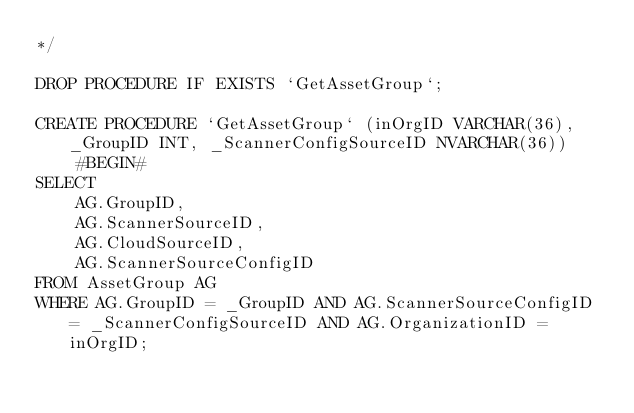<code> <loc_0><loc_0><loc_500><loc_500><_SQL_>*/

DROP PROCEDURE IF EXISTS `GetAssetGroup`;

CREATE PROCEDURE `GetAssetGroup` (inOrgID VARCHAR(36), _GroupID INT, _ScannerConfigSourceID NVARCHAR(36))
    #BEGIN#
SELECT
    AG.GroupID,
    AG.ScannerSourceID,
    AG.CloudSourceID,
    AG.ScannerSourceConfigID
FROM AssetGroup AG
WHERE AG.GroupID = _GroupID AND AG.ScannerSourceConfigID = _ScannerConfigSourceID AND AG.OrganizationID = inOrgID;</code> 